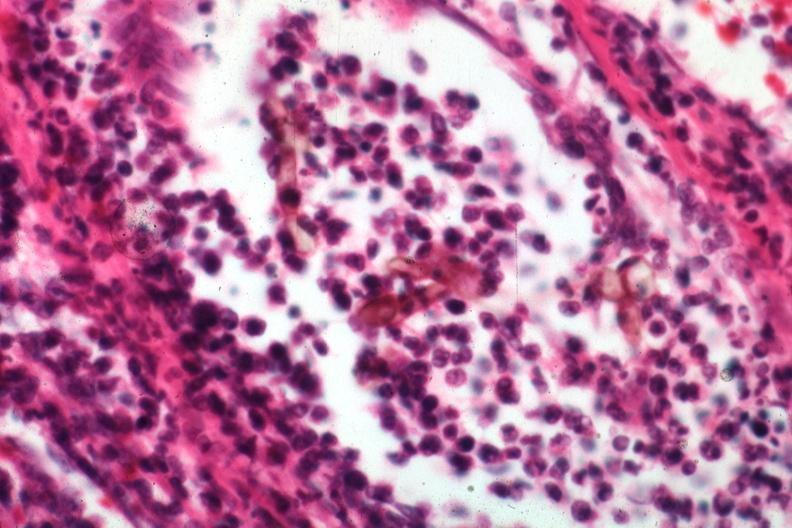s chromoblastomycosis present?
Answer the question using a single word or phrase. Yes 